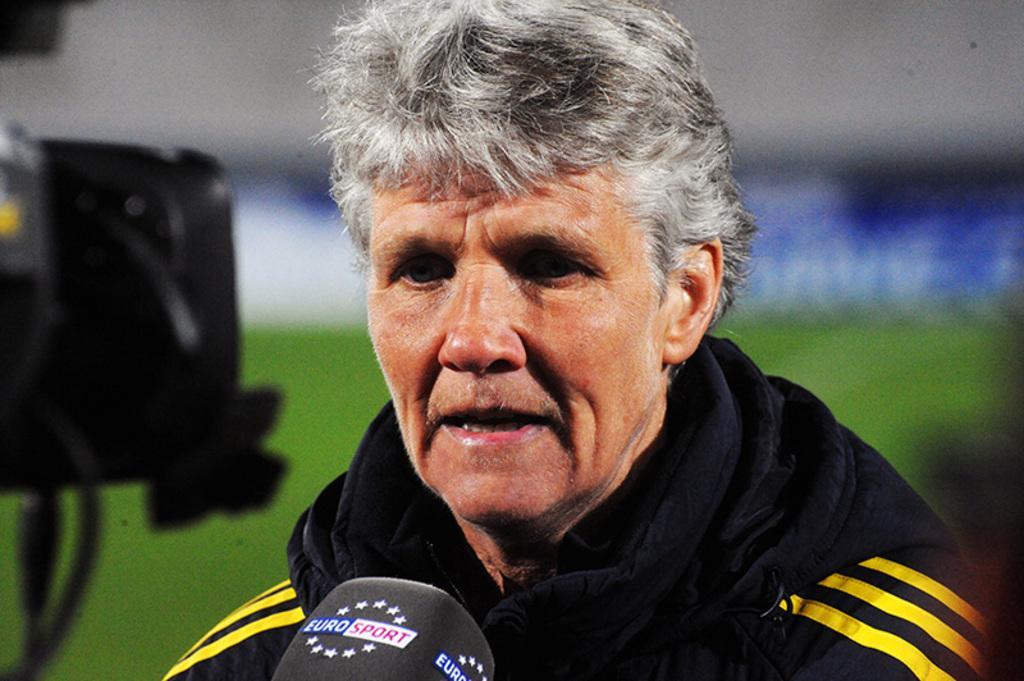Can you describe this image briefly? The old man in the front of the picture wearing black jacket is talking on the microphone. Beside him, we see a black color thing. In the background, we see grass and a board in blue and white color. It is blurred in the background. 